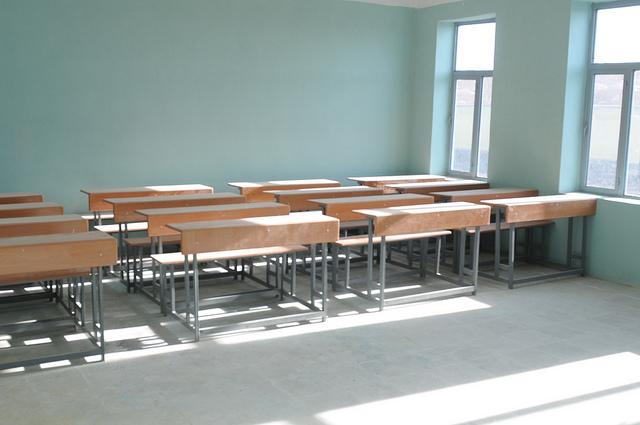What is this room probably used for?
Keep it brief. School. Are these desks occupied?
Concise answer only. No. Is this a classroom?
Keep it brief. Yes. 